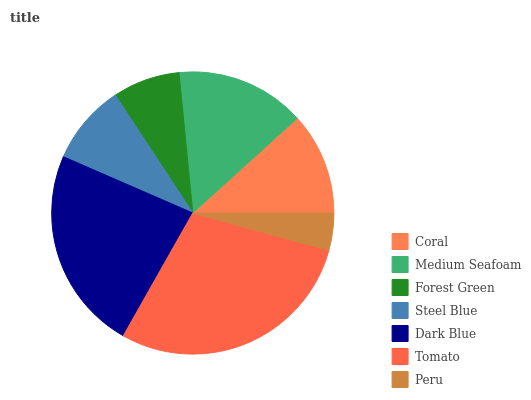Is Peru the minimum?
Answer yes or no. Yes. Is Tomato the maximum?
Answer yes or no. Yes. Is Medium Seafoam the minimum?
Answer yes or no. No. Is Medium Seafoam the maximum?
Answer yes or no. No. Is Medium Seafoam greater than Coral?
Answer yes or no. Yes. Is Coral less than Medium Seafoam?
Answer yes or no. Yes. Is Coral greater than Medium Seafoam?
Answer yes or no. No. Is Medium Seafoam less than Coral?
Answer yes or no. No. Is Coral the high median?
Answer yes or no. Yes. Is Coral the low median?
Answer yes or no. Yes. Is Peru the high median?
Answer yes or no. No. Is Peru the low median?
Answer yes or no. No. 